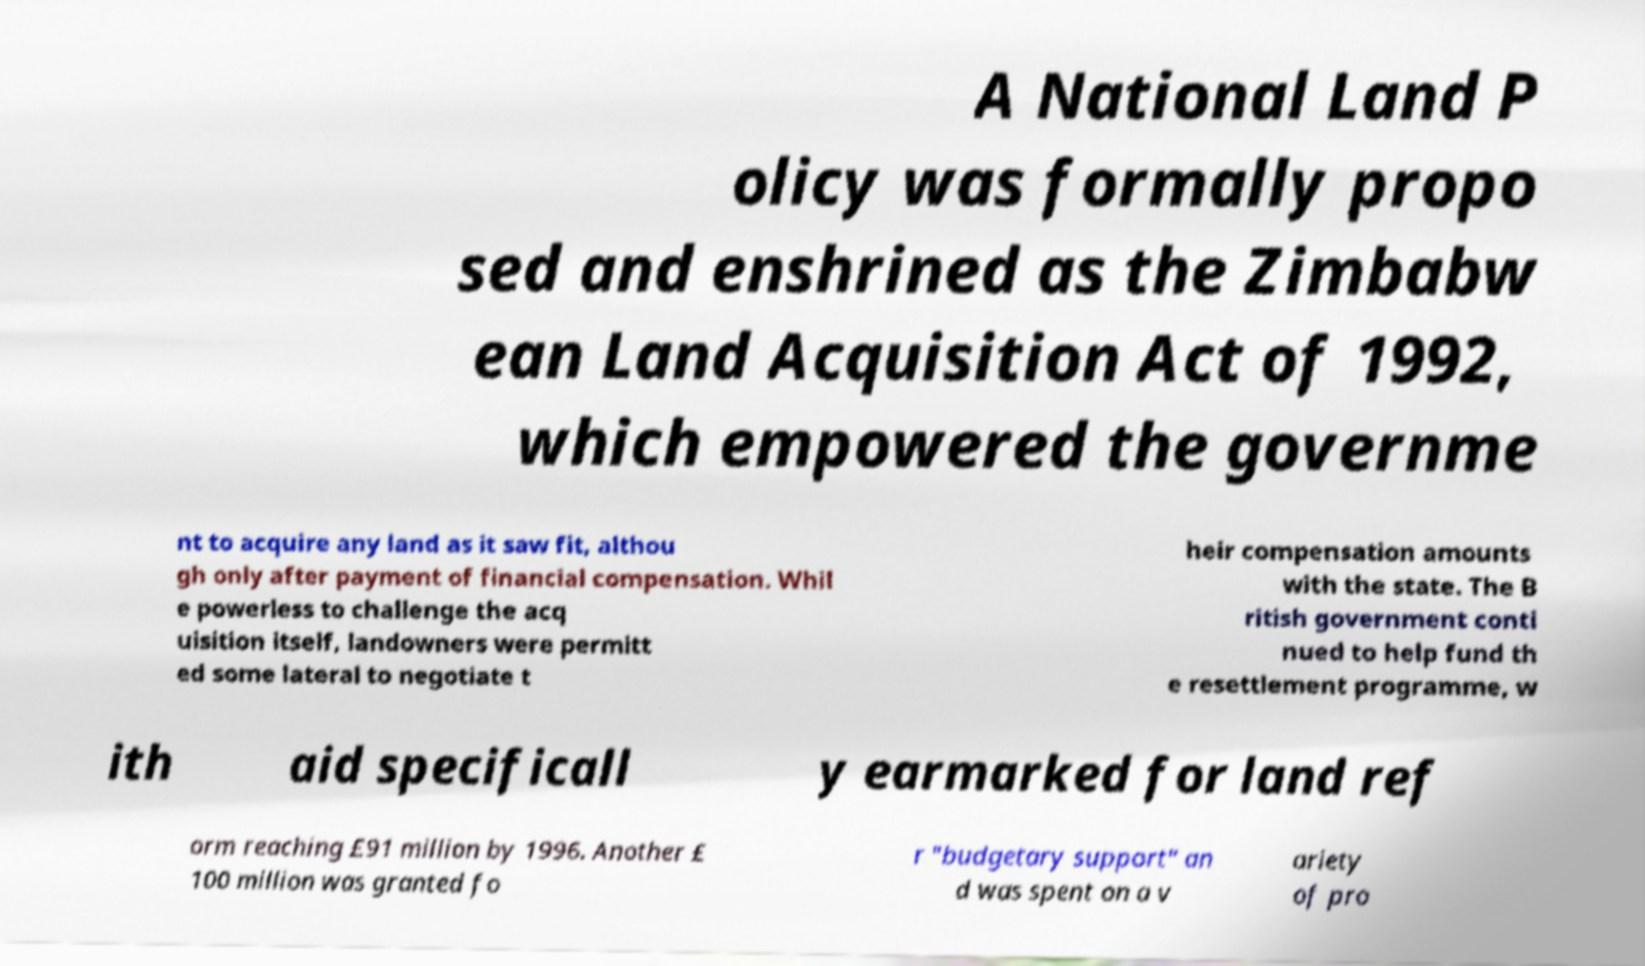I need the written content from this picture converted into text. Can you do that? A National Land P olicy was formally propo sed and enshrined as the Zimbabw ean Land Acquisition Act of 1992, which empowered the governme nt to acquire any land as it saw fit, althou gh only after payment of financial compensation. Whil e powerless to challenge the acq uisition itself, landowners were permitt ed some lateral to negotiate t heir compensation amounts with the state. The B ritish government conti nued to help fund th e resettlement programme, w ith aid specificall y earmarked for land ref orm reaching £91 million by 1996. Another £ 100 million was granted fo r "budgetary support" an d was spent on a v ariety of pro 